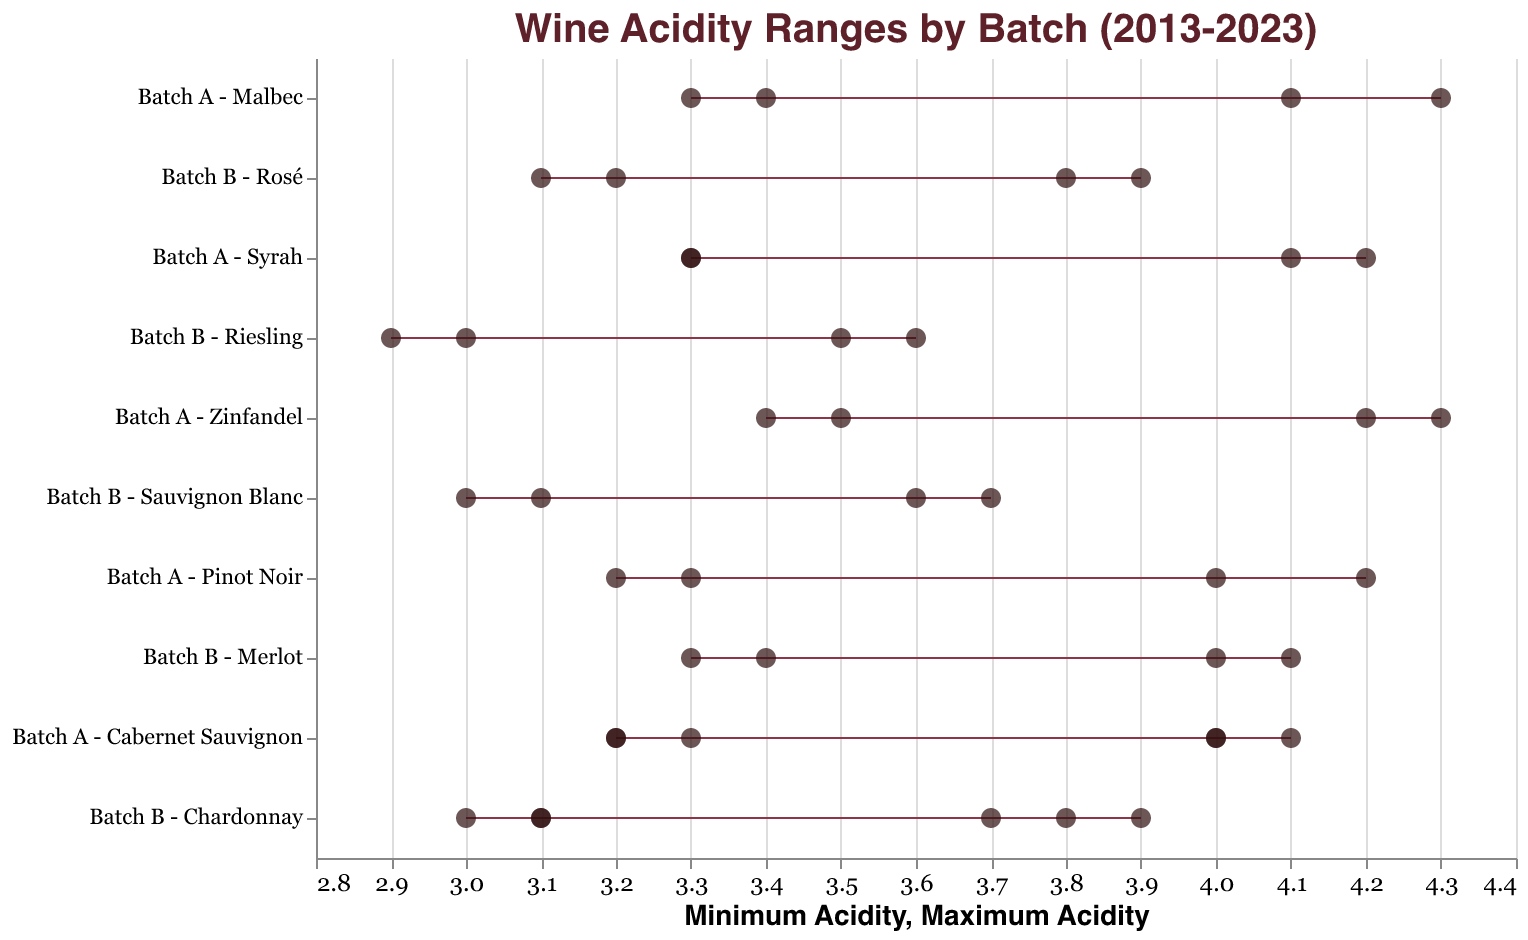What is the title of the figure? The title is located at the top of the figure and provides a descriptive label for the plot.
Answer: Wine Acidity Ranges by Batch (2013-2023) What is the range of acidity for Batch A - Zinfandel in 2018? Locate the horizontal range bar for Batch A - Zinfandel in 2018. The range endpoints on the x-axis show the minimum and maximum acidity values.
Answer: 3.5 to 4.3 Which batch has the lowest minimum acidity level and what is it? Identify the horizontal range bar with the lowest starting point on the x-axis. Refer to the y-axis for the batch name and the x-axis for the value.
Answer: Batch B - Riesling, 2.9 Between 2016 and 2023, which batch shows the largest spread in acidity levels? Calculate the spread (difference between maximum and minimum) for each batch within the specified years and find the greatest value.
Answer: Batch A - Zinfandel in 2018 How does the acidity range of Batch B - Rosé in 2023 compare to its range in 2022? Compare the horizontal range bars for Batch B - Rosé in 2023 and 2022. Look at the starting and ending points on the x-axis for both years.
Answer: 2023 (3.2 to 3.9) is higher than 2022 (3.1 to 3.8) Which year had the highest maximum acidity level and for which batch? Identify the highest endpoint on the x-axis for the maximum acidity levels and refer to the corresponding y-axis for the year and batch.
Answer: 2018, Batch A - Zinfandel What is the average minimum acidity for all batches in 2020? Add the minimum acidity levels for both batches in 2020 and divide by the number of batches. Calculation: (3.3 + 2.9) / 2 = 3.1
Answer: 3.1 Which batches have a maximum acidity level greater than 4.0 in 2021? Identify all horizontal range bars in 2021 that extend beyond the 4.0 mark on the x-axis. Refer to the y-axis for the batch names.
Answer: Batch A - Syrah In which year did Batch A - Malbec have a larger acidity range, 2022 or 2023? Compare the lengths of the horizontal range bars for Batch A - Malbec in both 2022 and 2023. The longer bar represents the larger range.
Answer: 2022 What is the minimum and maximum acidity range difference for Batch B - Chardonnay between 2013 and 2015? Calculate the difference in both minimum and maximum acidity levels for Batch B - Chardonnay between 2013 and 2015. Minimum: 3.1 - 3.0 = 0.1, Maximum: 3.9 - 3.7 = 0.2
Answer: Minimum 0.1, Maximum 0.2 